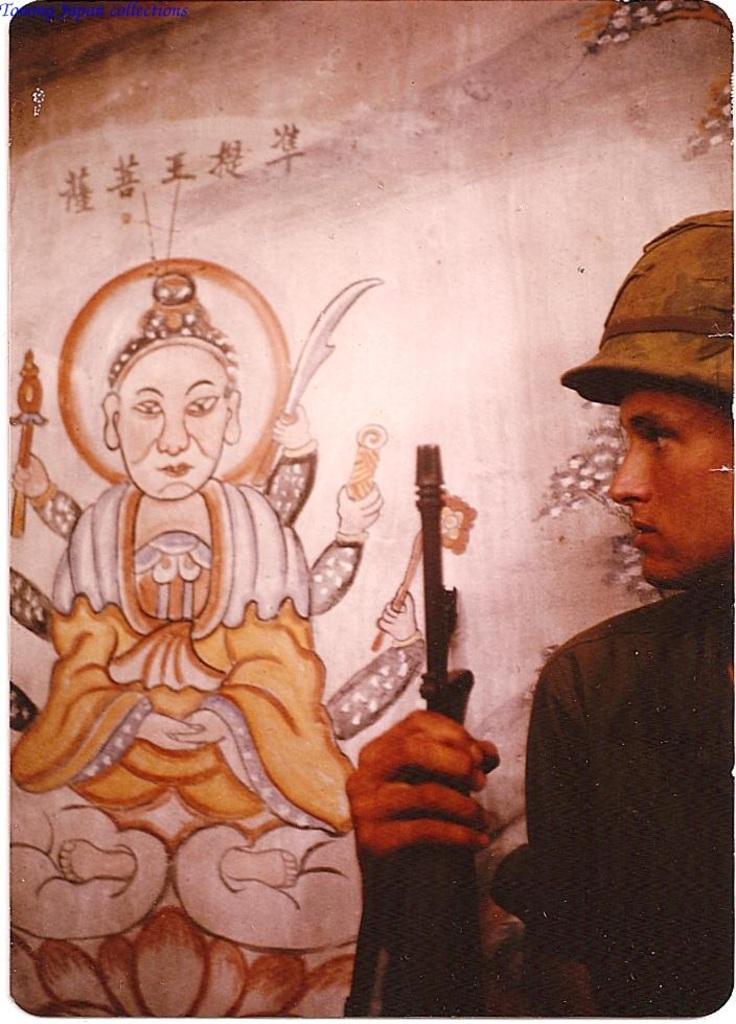Describe this image in one or two sentences. In this image we can see a person holding the gun and in the background, we can see a painting on the wall. 